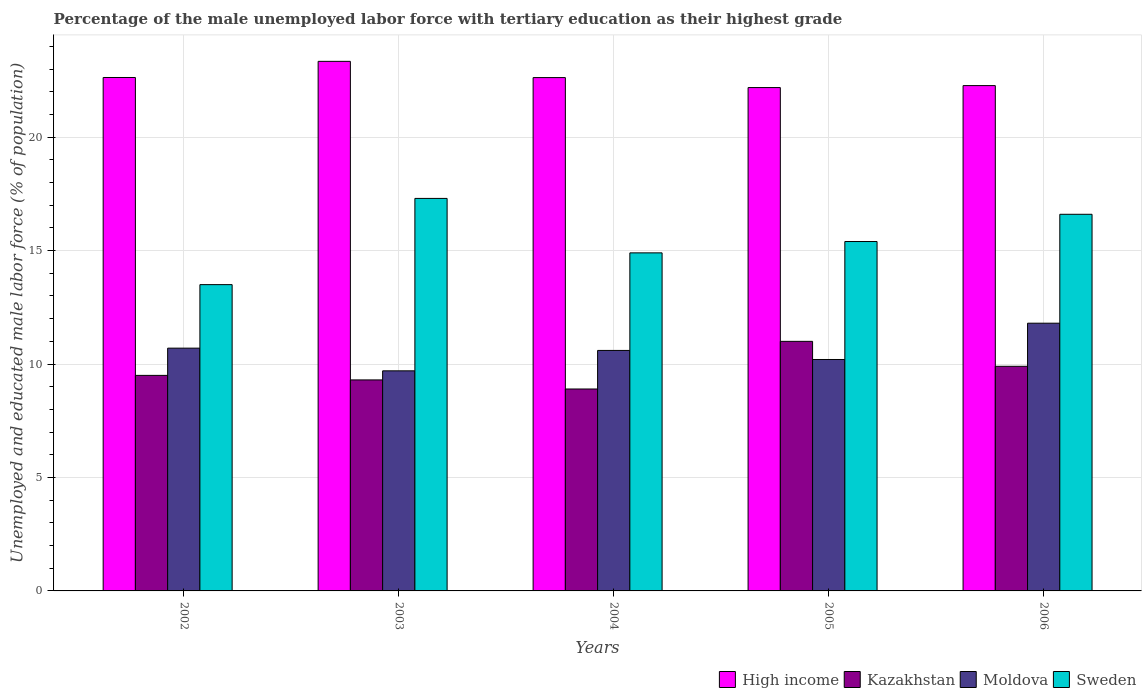How many groups of bars are there?
Offer a very short reply. 5. Are the number of bars per tick equal to the number of legend labels?
Ensure brevity in your answer.  Yes. Are the number of bars on each tick of the X-axis equal?
Your response must be concise. Yes. What is the label of the 1st group of bars from the left?
Provide a succinct answer. 2002. In how many cases, is the number of bars for a given year not equal to the number of legend labels?
Ensure brevity in your answer.  0. What is the percentage of the unemployed male labor force with tertiary education in Sweden in 2002?
Provide a succinct answer. 13.5. Across all years, what is the maximum percentage of the unemployed male labor force with tertiary education in High income?
Your answer should be compact. 23.34. Across all years, what is the minimum percentage of the unemployed male labor force with tertiary education in Kazakhstan?
Give a very brief answer. 8.9. What is the total percentage of the unemployed male labor force with tertiary education in Kazakhstan in the graph?
Offer a very short reply. 48.6. What is the difference between the percentage of the unemployed male labor force with tertiary education in Sweden in 2004 and that in 2005?
Make the answer very short. -0.5. What is the difference between the percentage of the unemployed male labor force with tertiary education in Kazakhstan in 2003 and the percentage of the unemployed male labor force with tertiary education in Sweden in 2002?
Provide a succinct answer. -4.2. What is the average percentage of the unemployed male labor force with tertiary education in High income per year?
Provide a short and direct response. 22.61. In the year 2005, what is the difference between the percentage of the unemployed male labor force with tertiary education in High income and percentage of the unemployed male labor force with tertiary education in Sweden?
Provide a succinct answer. 6.79. In how many years, is the percentage of the unemployed male labor force with tertiary education in Kazakhstan greater than 15 %?
Ensure brevity in your answer.  0. What is the ratio of the percentage of the unemployed male labor force with tertiary education in Moldova in 2003 to that in 2006?
Your response must be concise. 0.82. Is the difference between the percentage of the unemployed male labor force with tertiary education in High income in 2003 and 2004 greater than the difference between the percentage of the unemployed male labor force with tertiary education in Sweden in 2003 and 2004?
Offer a terse response. No. What is the difference between the highest and the second highest percentage of the unemployed male labor force with tertiary education in Sweden?
Give a very brief answer. 0.7. What is the difference between the highest and the lowest percentage of the unemployed male labor force with tertiary education in Kazakhstan?
Provide a short and direct response. 2.1. Is the sum of the percentage of the unemployed male labor force with tertiary education in Kazakhstan in 2003 and 2005 greater than the maximum percentage of the unemployed male labor force with tertiary education in High income across all years?
Your answer should be very brief. No. Is it the case that in every year, the sum of the percentage of the unemployed male labor force with tertiary education in Kazakhstan and percentage of the unemployed male labor force with tertiary education in Moldova is greater than the sum of percentage of the unemployed male labor force with tertiary education in High income and percentage of the unemployed male labor force with tertiary education in Sweden?
Offer a very short reply. No. What does the 3rd bar from the left in 2006 represents?
Keep it short and to the point. Moldova. What does the 1st bar from the right in 2002 represents?
Provide a succinct answer. Sweden. Is it the case that in every year, the sum of the percentage of the unemployed male labor force with tertiary education in Moldova and percentage of the unemployed male labor force with tertiary education in High income is greater than the percentage of the unemployed male labor force with tertiary education in Kazakhstan?
Give a very brief answer. Yes. How many bars are there?
Ensure brevity in your answer.  20. How many years are there in the graph?
Your answer should be compact. 5. What is the difference between two consecutive major ticks on the Y-axis?
Your answer should be very brief. 5. Are the values on the major ticks of Y-axis written in scientific E-notation?
Provide a short and direct response. No. Does the graph contain any zero values?
Provide a short and direct response. No. Where does the legend appear in the graph?
Provide a succinct answer. Bottom right. How are the legend labels stacked?
Offer a very short reply. Horizontal. What is the title of the graph?
Your response must be concise. Percentage of the male unemployed labor force with tertiary education as their highest grade. Does "Liberia" appear as one of the legend labels in the graph?
Your answer should be very brief. No. What is the label or title of the X-axis?
Offer a very short reply. Years. What is the label or title of the Y-axis?
Provide a succinct answer. Unemployed and educated male labor force (% of population). What is the Unemployed and educated male labor force (% of population) of High income in 2002?
Make the answer very short. 22.63. What is the Unemployed and educated male labor force (% of population) of Kazakhstan in 2002?
Your answer should be very brief. 9.5. What is the Unemployed and educated male labor force (% of population) of Moldova in 2002?
Provide a succinct answer. 10.7. What is the Unemployed and educated male labor force (% of population) in High income in 2003?
Give a very brief answer. 23.34. What is the Unemployed and educated male labor force (% of population) of Kazakhstan in 2003?
Provide a short and direct response. 9.3. What is the Unemployed and educated male labor force (% of population) in Moldova in 2003?
Make the answer very short. 9.7. What is the Unemployed and educated male labor force (% of population) in Sweden in 2003?
Your response must be concise. 17.3. What is the Unemployed and educated male labor force (% of population) of High income in 2004?
Your answer should be compact. 22.63. What is the Unemployed and educated male labor force (% of population) in Kazakhstan in 2004?
Ensure brevity in your answer.  8.9. What is the Unemployed and educated male labor force (% of population) of Moldova in 2004?
Make the answer very short. 10.6. What is the Unemployed and educated male labor force (% of population) in Sweden in 2004?
Offer a terse response. 14.9. What is the Unemployed and educated male labor force (% of population) in High income in 2005?
Provide a short and direct response. 22.19. What is the Unemployed and educated male labor force (% of population) of Kazakhstan in 2005?
Your answer should be compact. 11. What is the Unemployed and educated male labor force (% of population) in Moldova in 2005?
Offer a terse response. 10.2. What is the Unemployed and educated male labor force (% of population) in Sweden in 2005?
Ensure brevity in your answer.  15.4. What is the Unemployed and educated male labor force (% of population) in High income in 2006?
Keep it short and to the point. 22.27. What is the Unemployed and educated male labor force (% of population) in Kazakhstan in 2006?
Offer a very short reply. 9.9. What is the Unemployed and educated male labor force (% of population) in Moldova in 2006?
Offer a terse response. 11.8. What is the Unemployed and educated male labor force (% of population) of Sweden in 2006?
Ensure brevity in your answer.  16.6. Across all years, what is the maximum Unemployed and educated male labor force (% of population) of High income?
Offer a terse response. 23.34. Across all years, what is the maximum Unemployed and educated male labor force (% of population) in Moldova?
Give a very brief answer. 11.8. Across all years, what is the maximum Unemployed and educated male labor force (% of population) of Sweden?
Provide a short and direct response. 17.3. Across all years, what is the minimum Unemployed and educated male labor force (% of population) in High income?
Make the answer very short. 22.19. Across all years, what is the minimum Unemployed and educated male labor force (% of population) of Kazakhstan?
Ensure brevity in your answer.  8.9. Across all years, what is the minimum Unemployed and educated male labor force (% of population) in Moldova?
Give a very brief answer. 9.7. What is the total Unemployed and educated male labor force (% of population) of High income in the graph?
Your response must be concise. 113.05. What is the total Unemployed and educated male labor force (% of population) in Kazakhstan in the graph?
Your answer should be very brief. 48.6. What is the total Unemployed and educated male labor force (% of population) of Moldova in the graph?
Your answer should be very brief. 53. What is the total Unemployed and educated male labor force (% of population) of Sweden in the graph?
Keep it short and to the point. 77.7. What is the difference between the Unemployed and educated male labor force (% of population) of High income in 2002 and that in 2003?
Make the answer very short. -0.71. What is the difference between the Unemployed and educated male labor force (% of population) of Kazakhstan in 2002 and that in 2003?
Provide a succinct answer. 0.2. What is the difference between the Unemployed and educated male labor force (% of population) in Moldova in 2002 and that in 2003?
Provide a succinct answer. 1. What is the difference between the Unemployed and educated male labor force (% of population) of Sweden in 2002 and that in 2003?
Offer a terse response. -3.8. What is the difference between the Unemployed and educated male labor force (% of population) of High income in 2002 and that in 2004?
Provide a short and direct response. 0. What is the difference between the Unemployed and educated male labor force (% of population) of Kazakhstan in 2002 and that in 2004?
Keep it short and to the point. 0.6. What is the difference between the Unemployed and educated male labor force (% of population) in High income in 2002 and that in 2005?
Your answer should be compact. 0.44. What is the difference between the Unemployed and educated male labor force (% of population) in Kazakhstan in 2002 and that in 2005?
Give a very brief answer. -1.5. What is the difference between the Unemployed and educated male labor force (% of population) of Moldova in 2002 and that in 2005?
Your response must be concise. 0.5. What is the difference between the Unemployed and educated male labor force (% of population) in High income in 2002 and that in 2006?
Ensure brevity in your answer.  0.36. What is the difference between the Unemployed and educated male labor force (% of population) of Sweden in 2002 and that in 2006?
Keep it short and to the point. -3.1. What is the difference between the Unemployed and educated male labor force (% of population) in High income in 2003 and that in 2004?
Keep it short and to the point. 0.72. What is the difference between the Unemployed and educated male labor force (% of population) of High income in 2003 and that in 2005?
Ensure brevity in your answer.  1.16. What is the difference between the Unemployed and educated male labor force (% of population) of Kazakhstan in 2003 and that in 2005?
Your answer should be very brief. -1.7. What is the difference between the Unemployed and educated male labor force (% of population) in Moldova in 2003 and that in 2005?
Ensure brevity in your answer.  -0.5. What is the difference between the Unemployed and educated male labor force (% of population) in High income in 2003 and that in 2006?
Make the answer very short. 1.07. What is the difference between the Unemployed and educated male labor force (% of population) of Kazakhstan in 2003 and that in 2006?
Make the answer very short. -0.6. What is the difference between the Unemployed and educated male labor force (% of population) in Moldova in 2003 and that in 2006?
Provide a succinct answer. -2.1. What is the difference between the Unemployed and educated male labor force (% of population) of High income in 2004 and that in 2005?
Keep it short and to the point. 0.44. What is the difference between the Unemployed and educated male labor force (% of population) in Sweden in 2004 and that in 2005?
Give a very brief answer. -0.5. What is the difference between the Unemployed and educated male labor force (% of population) of High income in 2004 and that in 2006?
Your answer should be compact. 0.35. What is the difference between the Unemployed and educated male labor force (% of population) of Moldova in 2004 and that in 2006?
Give a very brief answer. -1.2. What is the difference between the Unemployed and educated male labor force (% of population) of Sweden in 2004 and that in 2006?
Your answer should be very brief. -1.7. What is the difference between the Unemployed and educated male labor force (% of population) in High income in 2005 and that in 2006?
Offer a terse response. -0.09. What is the difference between the Unemployed and educated male labor force (% of population) in High income in 2002 and the Unemployed and educated male labor force (% of population) in Kazakhstan in 2003?
Your response must be concise. 13.33. What is the difference between the Unemployed and educated male labor force (% of population) of High income in 2002 and the Unemployed and educated male labor force (% of population) of Moldova in 2003?
Give a very brief answer. 12.93. What is the difference between the Unemployed and educated male labor force (% of population) of High income in 2002 and the Unemployed and educated male labor force (% of population) of Sweden in 2003?
Ensure brevity in your answer.  5.33. What is the difference between the Unemployed and educated male labor force (% of population) in Moldova in 2002 and the Unemployed and educated male labor force (% of population) in Sweden in 2003?
Your response must be concise. -6.6. What is the difference between the Unemployed and educated male labor force (% of population) in High income in 2002 and the Unemployed and educated male labor force (% of population) in Kazakhstan in 2004?
Keep it short and to the point. 13.73. What is the difference between the Unemployed and educated male labor force (% of population) of High income in 2002 and the Unemployed and educated male labor force (% of population) of Moldova in 2004?
Ensure brevity in your answer.  12.03. What is the difference between the Unemployed and educated male labor force (% of population) of High income in 2002 and the Unemployed and educated male labor force (% of population) of Sweden in 2004?
Ensure brevity in your answer.  7.73. What is the difference between the Unemployed and educated male labor force (% of population) in Kazakhstan in 2002 and the Unemployed and educated male labor force (% of population) in Moldova in 2004?
Your answer should be compact. -1.1. What is the difference between the Unemployed and educated male labor force (% of population) in Moldova in 2002 and the Unemployed and educated male labor force (% of population) in Sweden in 2004?
Offer a terse response. -4.2. What is the difference between the Unemployed and educated male labor force (% of population) in High income in 2002 and the Unemployed and educated male labor force (% of population) in Kazakhstan in 2005?
Your answer should be compact. 11.63. What is the difference between the Unemployed and educated male labor force (% of population) of High income in 2002 and the Unemployed and educated male labor force (% of population) of Moldova in 2005?
Your response must be concise. 12.43. What is the difference between the Unemployed and educated male labor force (% of population) in High income in 2002 and the Unemployed and educated male labor force (% of population) in Sweden in 2005?
Offer a very short reply. 7.23. What is the difference between the Unemployed and educated male labor force (% of population) of Kazakhstan in 2002 and the Unemployed and educated male labor force (% of population) of Sweden in 2005?
Provide a succinct answer. -5.9. What is the difference between the Unemployed and educated male labor force (% of population) in High income in 2002 and the Unemployed and educated male labor force (% of population) in Kazakhstan in 2006?
Offer a very short reply. 12.73. What is the difference between the Unemployed and educated male labor force (% of population) of High income in 2002 and the Unemployed and educated male labor force (% of population) of Moldova in 2006?
Your answer should be compact. 10.83. What is the difference between the Unemployed and educated male labor force (% of population) in High income in 2002 and the Unemployed and educated male labor force (% of population) in Sweden in 2006?
Your answer should be very brief. 6.03. What is the difference between the Unemployed and educated male labor force (% of population) of Moldova in 2002 and the Unemployed and educated male labor force (% of population) of Sweden in 2006?
Give a very brief answer. -5.9. What is the difference between the Unemployed and educated male labor force (% of population) of High income in 2003 and the Unemployed and educated male labor force (% of population) of Kazakhstan in 2004?
Make the answer very short. 14.44. What is the difference between the Unemployed and educated male labor force (% of population) of High income in 2003 and the Unemployed and educated male labor force (% of population) of Moldova in 2004?
Keep it short and to the point. 12.74. What is the difference between the Unemployed and educated male labor force (% of population) in High income in 2003 and the Unemployed and educated male labor force (% of population) in Sweden in 2004?
Your response must be concise. 8.44. What is the difference between the Unemployed and educated male labor force (% of population) of Kazakhstan in 2003 and the Unemployed and educated male labor force (% of population) of Sweden in 2004?
Your answer should be very brief. -5.6. What is the difference between the Unemployed and educated male labor force (% of population) in Moldova in 2003 and the Unemployed and educated male labor force (% of population) in Sweden in 2004?
Offer a terse response. -5.2. What is the difference between the Unemployed and educated male labor force (% of population) in High income in 2003 and the Unemployed and educated male labor force (% of population) in Kazakhstan in 2005?
Give a very brief answer. 12.34. What is the difference between the Unemployed and educated male labor force (% of population) of High income in 2003 and the Unemployed and educated male labor force (% of population) of Moldova in 2005?
Your answer should be compact. 13.14. What is the difference between the Unemployed and educated male labor force (% of population) in High income in 2003 and the Unemployed and educated male labor force (% of population) in Sweden in 2005?
Give a very brief answer. 7.94. What is the difference between the Unemployed and educated male labor force (% of population) of Kazakhstan in 2003 and the Unemployed and educated male labor force (% of population) of Moldova in 2005?
Provide a short and direct response. -0.9. What is the difference between the Unemployed and educated male labor force (% of population) in Kazakhstan in 2003 and the Unemployed and educated male labor force (% of population) in Sweden in 2005?
Your answer should be compact. -6.1. What is the difference between the Unemployed and educated male labor force (% of population) of Moldova in 2003 and the Unemployed and educated male labor force (% of population) of Sweden in 2005?
Ensure brevity in your answer.  -5.7. What is the difference between the Unemployed and educated male labor force (% of population) of High income in 2003 and the Unemployed and educated male labor force (% of population) of Kazakhstan in 2006?
Offer a terse response. 13.44. What is the difference between the Unemployed and educated male labor force (% of population) of High income in 2003 and the Unemployed and educated male labor force (% of population) of Moldova in 2006?
Provide a short and direct response. 11.54. What is the difference between the Unemployed and educated male labor force (% of population) of High income in 2003 and the Unemployed and educated male labor force (% of population) of Sweden in 2006?
Your response must be concise. 6.74. What is the difference between the Unemployed and educated male labor force (% of population) of Kazakhstan in 2003 and the Unemployed and educated male labor force (% of population) of Moldova in 2006?
Provide a succinct answer. -2.5. What is the difference between the Unemployed and educated male labor force (% of population) of Moldova in 2003 and the Unemployed and educated male labor force (% of population) of Sweden in 2006?
Offer a very short reply. -6.9. What is the difference between the Unemployed and educated male labor force (% of population) in High income in 2004 and the Unemployed and educated male labor force (% of population) in Kazakhstan in 2005?
Your response must be concise. 11.63. What is the difference between the Unemployed and educated male labor force (% of population) in High income in 2004 and the Unemployed and educated male labor force (% of population) in Moldova in 2005?
Give a very brief answer. 12.43. What is the difference between the Unemployed and educated male labor force (% of population) in High income in 2004 and the Unemployed and educated male labor force (% of population) in Sweden in 2005?
Give a very brief answer. 7.23. What is the difference between the Unemployed and educated male labor force (% of population) of Moldova in 2004 and the Unemployed and educated male labor force (% of population) of Sweden in 2005?
Your answer should be very brief. -4.8. What is the difference between the Unemployed and educated male labor force (% of population) in High income in 2004 and the Unemployed and educated male labor force (% of population) in Kazakhstan in 2006?
Your response must be concise. 12.73. What is the difference between the Unemployed and educated male labor force (% of population) of High income in 2004 and the Unemployed and educated male labor force (% of population) of Moldova in 2006?
Your response must be concise. 10.83. What is the difference between the Unemployed and educated male labor force (% of population) of High income in 2004 and the Unemployed and educated male labor force (% of population) of Sweden in 2006?
Provide a short and direct response. 6.03. What is the difference between the Unemployed and educated male labor force (% of population) of Kazakhstan in 2004 and the Unemployed and educated male labor force (% of population) of Moldova in 2006?
Provide a short and direct response. -2.9. What is the difference between the Unemployed and educated male labor force (% of population) in Moldova in 2004 and the Unemployed and educated male labor force (% of population) in Sweden in 2006?
Provide a succinct answer. -6. What is the difference between the Unemployed and educated male labor force (% of population) in High income in 2005 and the Unemployed and educated male labor force (% of population) in Kazakhstan in 2006?
Your answer should be compact. 12.29. What is the difference between the Unemployed and educated male labor force (% of population) in High income in 2005 and the Unemployed and educated male labor force (% of population) in Moldova in 2006?
Keep it short and to the point. 10.38. What is the difference between the Unemployed and educated male labor force (% of population) of High income in 2005 and the Unemployed and educated male labor force (% of population) of Sweden in 2006?
Make the answer very short. 5.58. What is the difference between the Unemployed and educated male labor force (% of population) of Kazakhstan in 2005 and the Unemployed and educated male labor force (% of population) of Moldova in 2006?
Your response must be concise. -0.8. What is the average Unemployed and educated male labor force (% of population) of High income per year?
Provide a short and direct response. 22.61. What is the average Unemployed and educated male labor force (% of population) in Kazakhstan per year?
Provide a succinct answer. 9.72. What is the average Unemployed and educated male labor force (% of population) of Moldova per year?
Provide a short and direct response. 10.6. What is the average Unemployed and educated male labor force (% of population) of Sweden per year?
Offer a terse response. 15.54. In the year 2002, what is the difference between the Unemployed and educated male labor force (% of population) in High income and Unemployed and educated male labor force (% of population) in Kazakhstan?
Provide a succinct answer. 13.13. In the year 2002, what is the difference between the Unemployed and educated male labor force (% of population) of High income and Unemployed and educated male labor force (% of population) of Moldova?
Provide a succinct answer. 11.93. In the year 2002, what is the difference between the Unemployed and educated male labor force (% of population) of High income and Unemployed and educated male labor force (% of population) of Sweden?
Keep it short and to the point. 9.13. In the year 2002, what is the difference between the Unemployed and educated male labor force (% of population) in Kazakhstan and Unemployed and educated male labor force (% of population) in Sweden?
Provide a succinct answer. -4. In the year 2003, what is the difference between the Unemployed and educated male labor force (% of population) in High income and Unemployed and educated male labor force (% of population) in Kazakhstan?
Provide a short and direct response. 14.04. In the year 2003, what is the difference between the Unemployed and educated male labor force (% of population) of High income and Unemployed and educated male labor force (% of population) of Moldova?
Offer a very short reply. 13.64. In the year 2003, what is the difference between the Unemployed and educated male labor force (% of population) of High income and Unemployed and educated male labor force (% of population) of Sweden?
Provide a succinct answer. 6.04. In the year 2003, what is the difference between the Unemployed and educated male labor force (% of population) in Kazakhstan and Unemployed and educated male labor force (% of population) in Sweden?
Ensure brevity in your answer.  -8. In the year 2004, what is the difference between the Unemployed and educated male labor force (% of population) of High income and Unemployed and educated male labor force (% of population) of Kazakhstan?
Make the answer very short. 13.73. In the year 2004, what is the difference between the Unemployed and educated male labor force (% of population) in High income and Unemployed and educated male labor force (% of population) in Moldova?
Your answer should be very brief. 12.03. In the year 2004, what is the difference between the Unemployed and educated male labor force (% of population) of High income and Unemployed and educated male labor force (% of population) of Sweden?
Make the answer very short. 7.73. In the year 2004, what is the difference between the Unemployed and educated male labor force (% of population) of Moldova and Unemployed and educated male labor force (% of population) of Sweden?
Make the answer very short. -4.3. In the year 2005, what is the difference between the Unemployed and educated male labor force (% of population) of High income and Unemployed and educated male labor force (% of population) of Kazakhstan?
Offer a very short reply. 11.19. In the year 2005, what is the difference between the Unemployed and educated male labor force (% of population) of High income and Unemployed and educated male labor force (% of population) of Moldova?
Your answer should be compact. 11.98. In the year 2005, what is the difference between the Unemployed and educated male labor force (% of population) in High income and Unemployed and educated male labor force (% of population) in Sweden?
Ensure brevity in your answer.  6.79. In the year 2005, what is the difference between the Unemployed and educated male labor force (% of population) in Kazakhstan and Unemployed and educated male labor force (% of population) in Moldova?
Your response must be concise. 0.8. In the year 2005, what is the difference between the Unemployed and educated male labor force (% of population) of Kazakhstan and Unemployed and educated male labor force (% of population) of Sweden?
Give a very brief answer. -4.4. In the year 2006, what is the difference between the Unemployed and educated male labor force (% of population) of High income and Unemployed and educated male labor force (% of population) of Kazakhstan?
Your answer should be very brief. 12.37. In the year 2006, what is the difference between the Unemployed and educated male labor force (% of population) in High income and Unemployed and educated male labor force (% of population) in Moldova?
Offer a terse response. 10.47. In the year 2006, what is the difference between the Unemployed and educated male labor force (% of population) of High income and Unemployed and educated male labor force (% of population) of Sweden?
Provide a short and direct response. 5.67. In the year 2006, what is the difference between the Unemployed and educated male labor force (% of population) of Moldova and Unemployed and educated male labor force (% of population) of Sweden?
Offer a very short reply. -4.8. What is the ratio of the Unemployed and educated male labor force (% of population) in High income in 2002 to that in 2003?
Offer a terse response. 0.97. What is the ratio of the Unemployed and educated male labor force (% of population) in Kazakhstan in 2002 to that in 2003?
Make the answer very short. 1.02. What is the ratio of the Unemployed and educated male labor force (% of population) in Moldova in 2002 to that in 2003?
Your answer should be compact. 1.1. What is the ratio of the Unemployed and educated male labor force (% of population) in Sweden in 2002 to that in 2003?
Ensure brevity in your answer.  0.78. What is the ratio of the Unemployed and educated male labor force (% of population) in Kazakhstan in 2002 to that in 2004?
Your answer should be very brief. 1.07. What is the ratio of the Unemployed and educated male labor force (% of population) of Moldova in 2002 to that in 2004?
Offer a terse response. 1.01. What is the ratio of the Unemployed and educated male labor force (% of population) in Sweden in 2002 to that in 2004?
Offer a terse response. 0.91. What is the ratio of the Unemployed and educated male labor force (% of population) of High income in 2002 to that in 2005?
Provide a succinct answer. 1.02. What is the ratio of the Unemployed and educated male labor force (% of population) of Kazakhstan in 2002 to that in 2005?
Provide a short and direct response. 0.86. What is the ratio of the Unemployed and educated male labor force (% of population) of Moldova in 2002 to that in 2005?
Offer a terse response. 1.05. What is the ratio of the Unemployed and educated male labor force (% of population) in Sweden in 2002 to that in 2005?
Your answer should be compact. 0.88. What is the ratio of the Unemployed and educated male labor force (% of population) in High income in 2002 to that in 2006?
Keep it short and to the point. 1.02. What is the ratio of the Unemployed and educated male labor force (% of population) in Kazakhstan in 2002 to that in 2006?
Your answer should be very brief. 0.96. What is the ratio of the Unemployed and educated male labor force (% of population) in Moldova in 2002 to that in 2006?
Make the answer very short. 0.91. What is the ratio of the Unemployed and educated male labor force (% of population) of Sweden in 2002 to that in 2006?
Your answer should be compact. 0.81. What is the ratio of the Unemployed and educated male labor force (% of population) in High income in 2003 to that in 2004?
Your response must be concise. 1.03. What is the ratio of the Unemployed and educated male labor force (% of population) of Kazakhstan in 2003 to that in 2004?
Offer a terse response. 1.04. What is the ratio of the Unemployed and educated male labor force (% of population) in Moldova in 2003 to that in 2004?
Ensure brevity in your answer.  0.92. What is the ratio of the Unemployed and educated male labor force (% of population) in Sweden in 2003 to that in 2004?
Give a very brief answer. 1.16. What is the ratio of the Unemployed and educated male labor force (% of population) of High income in 2003 to that in 2005?
Give a very brief answer. 1.05. What is the ratio of the Unemployed and educated male labor force (% of population) in Kazakhstan in 2003 to that in 2005?
Give a very brief answer. 0.85. What is the ratio of the Unemployed and educated male labor force (% of population) in Moldova in 2003 to that in 2005?
Provide a short and direct response. 0.95. What is the ratio of the Unemployed and educated male labor force (% of population) in Sweden in 2003 to that in 2005?
Your answer should be very brief. 1.12. What is the ratio of the Unemployed and educated male labor force (% of population) in High income in 2003 to that in 2006?
Provide a succinct answer. 1.05. What is the ratio of the Unemployed and educated male labor force (% of population) in Kazakhstan in 2003 to that in 2006?
Keep it short and to the point. 0.94. What is the ratio of the Unemployed and educated male labor force (% of population) in Moldova in 2003 to that in 2006?
Ensure brevity in your answer.  0.82. What is the ratio of the Unemployed and educated male labor force (% of population) of Sweden in 2003 to that in 2006?
Ensure brevity in your answer.  1.04. What is the ratio of the Unemployed and educated male labor force (% of population) of High income in 2004 to that in 2005?
Offer a very short reply. 1.02. What is the ratio of the Unemployed and educated male labor force (% of population) in Kazakhstan in 2004 to that in 2005?
Provide a short and direct response. 0.81. What is the ratio of the Unemployed and educated male labor force (% of population) of Moldova in 2004 to that in 2005?
Give a very brief answer. 1.04. What is the ratio of the Unemployed and educated male labor force (% of population) in Sweden in 2004 to that in 2005?
Your answer should be very brief. 0.97. What is the ratio of the Unemployed and educated male labor force (% of population) in High income in 2004 to that in 2006?
Your answer should be very brief. 1.02. What is the ratio of the Unemployed and educated male labor force (% of population) of Kazakhstan in 2004 to that in 2006?
Make the answer very short. 0.9. What is the ratio of the Unemployed and educated male labor force (% of population) of Moldova in 2004 to that in 2006?
Keep it short and to the point. 0.9. What is the ratio of the Unemployed and educated male labor force (% of population) in Sweden in 2004 to that in 2006?
Your answer should be very brief. 0.9. What is the ratio of the Unemployed and educated male labor force (% of population) of High income in 2005 to that in 2006?
Provide a short and direct response. 1. What is the ratio of the Unemployed and educated male labor force (% of population) in Moldova in 2005 to that in 2006?
Ensure brevity in your answer.  0.86. What is the ratio of the Unemployed and educated male labor force (% of population) of Sweden in 2005 to that in 2006?
Your response must be concise. 0.93. What is the difference between the highest and the second highest Unemployed and educated male labor force (% of population) in High income?
Ensure brevity in your answer.  0.71. What is the difference between the highest and the second highest Unemployed and educated male labor force (% of population) in Kazakhstan?
Your answer should be compact. 1.1. What is the difference between the highest and the second highest Unemployed and educated male labor force (% of population) in Sweden?
Make the answer very short. 0.7. What is the difference between the highest and the lowest Unemployed and educated male labor force (% of population) in High income?
Make the answer very short. 1.16. What is the difference between the highest and the lowest Unemployed and educated male labor force (% of population) of Sweden?
Your answer should be very brief. 3.8. 